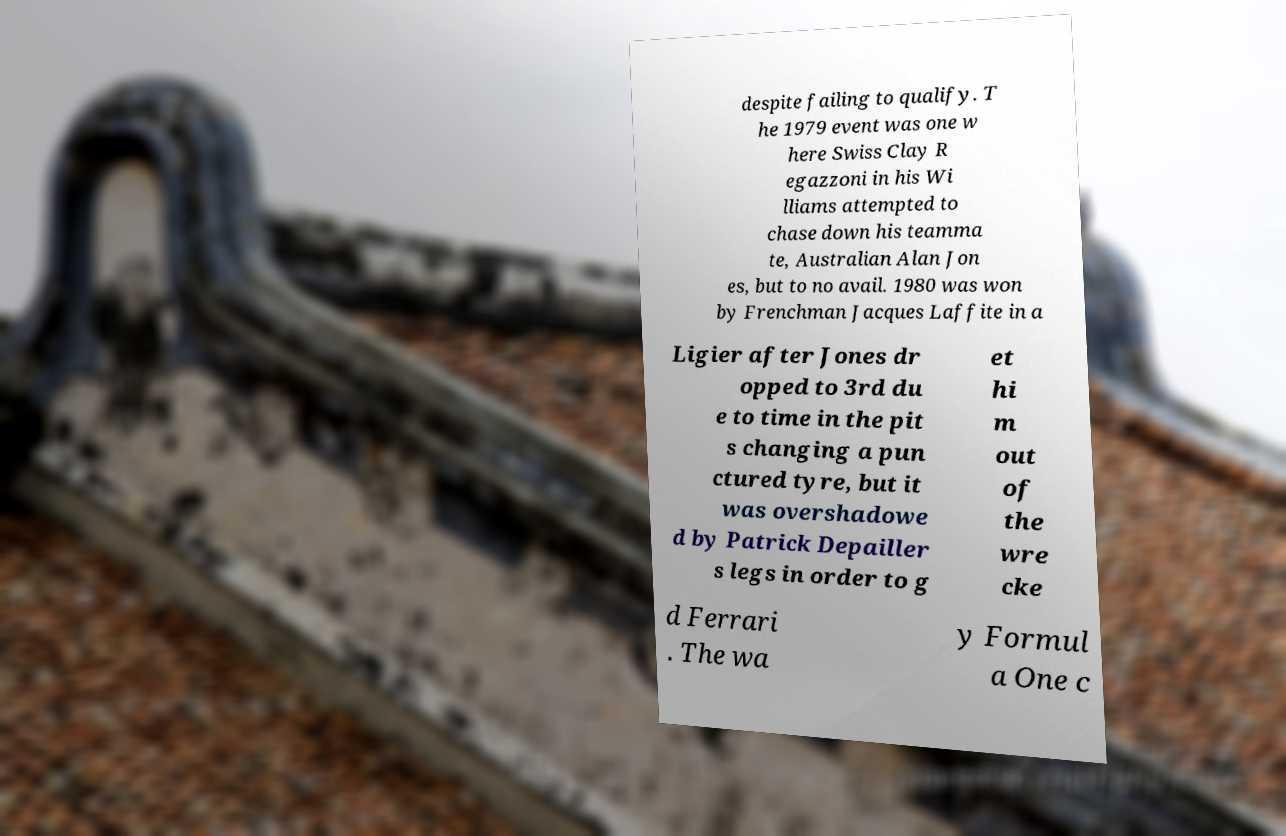Please read and relay the text visible in this image. What does it say? despite failing to qualify. T he 1979 event was one w here Swiss Clay R egazzoni in his Wi lliams attempted to chase down his teamma te, Australian Alan Jon es, but to no avail. 1980 was won by Frenchman Jacques Laffite in a Ligier after Jones dr opped to 3rd du e to time in the pit s changing a pun ctured tyre, but it was overshadowe d by Patrick Depailler s legs in order to g et hi m out of the wre cke d Ferrari . The wa y Formul a One c 